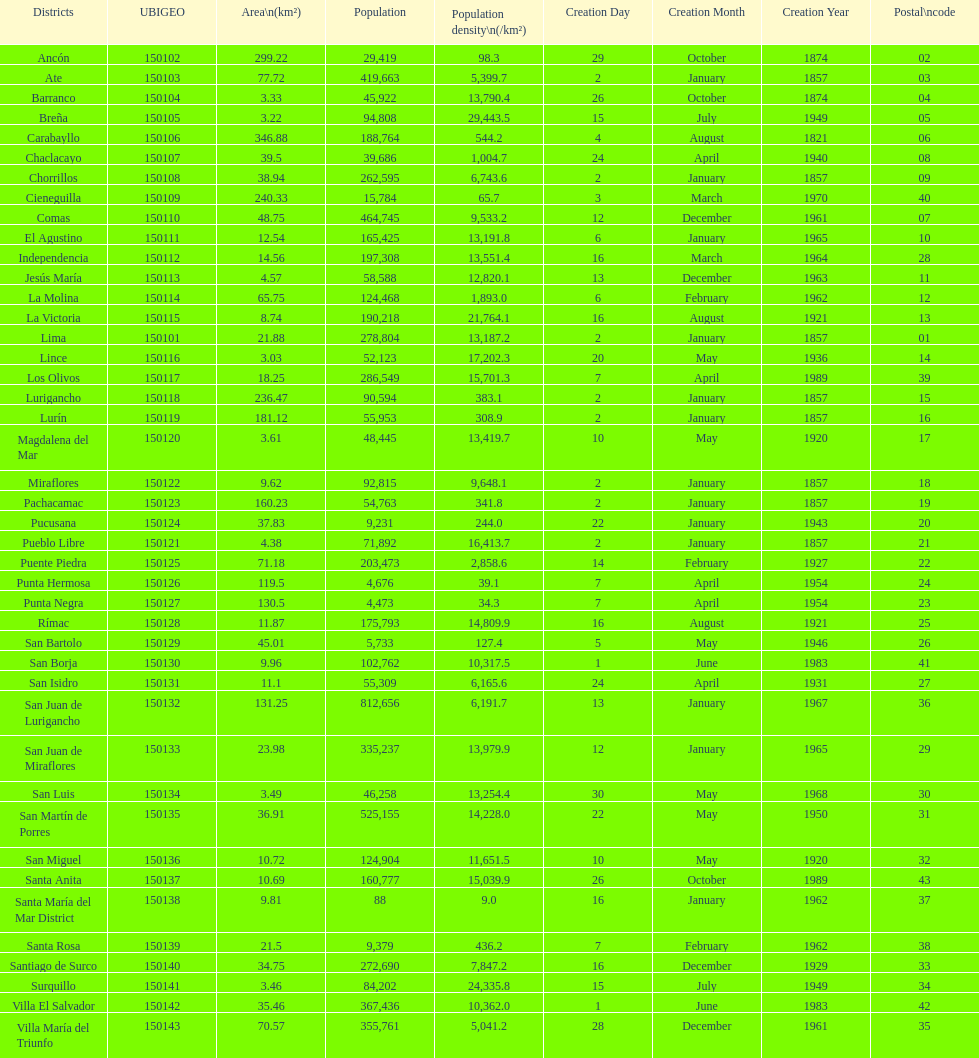Which district in this city has the greatest population? San Juan de Lurigancho. 